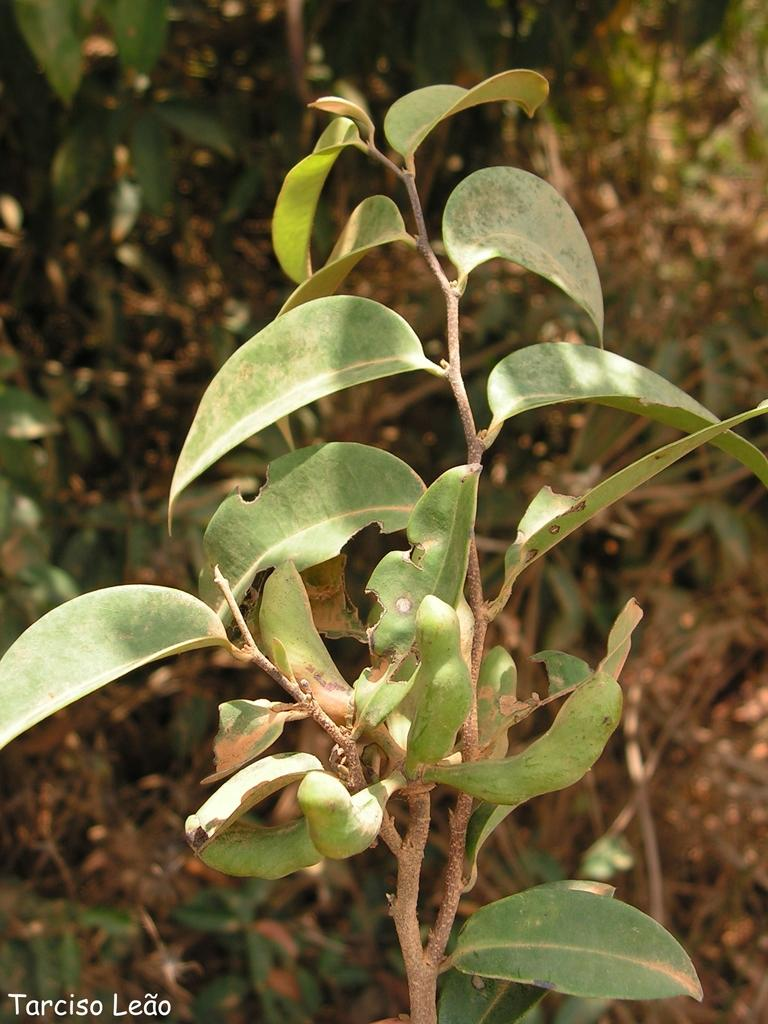What is the main subject in the center of the image? There is a plant in the center of the image. What can be seen in the background of the image? There are dried leaves and other plants visible in the background of the image. Where is the text located in the image? The text is in the bottom left corner of the image. How many boats are visible in the image? There are no boats present in the image. What type of oven is used to cook the plants in the image? There is no oven present in the image, and plants do not require cooking. 